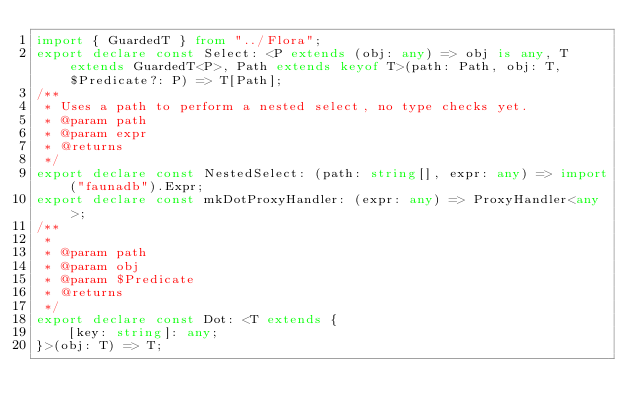<code> <loc_0><loc_0><loc_500><loc_500><_TypeScript_>import { GuardedT } from "../Flora";
export declare const Select: <P extends (obj: any) => obj is any, T extends GuardedT<P>, Path extends keyof T>(path: Path, obj: T, $Predicate?: P) => T[Path];
/**
 * Uses a path to perform a nested select, no type checks yet.
 * @param path
 * @param expr
 * @returns
 */
export declare const NestedSelect: (path: string[], expr: any) => import("faunadb").Expr;
export declare const mkDotProxyHandler: (expr: any) => ProxyHandler<any>;
/**
 *
 * @param path
 * @param obj
 * @param $Predicate
 * @returns
 */
export declare const Dot: <T extends {
    [key: string]: any;
}>(obj: T) => T;
</code> 